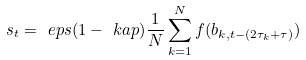<formula> <loc_0><loc_0><loc_500><loc_500>s _ { t } = \ e p s ( 1 - \ k a p ) \frac { 1 } { N } \sum _ { k = 1 } ^ { N } f ( b _ { k , t - ( 2 \tau _ { k } + \tau ) } )</formula> 